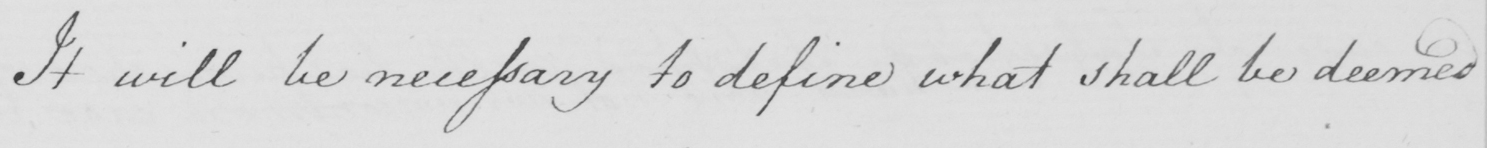Transcribe the text shown in this historical manuscript line. It will be necessary to define what shall be deemed 